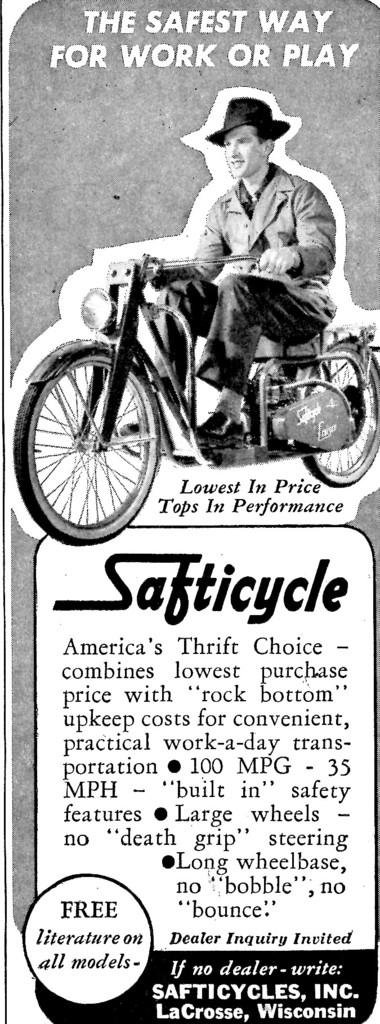What is the main subject of the image? There is an article in the image. What type of form is being filled out in the lunchroom in the image? There is no form or lunchroom present in the image; it only features an article. 